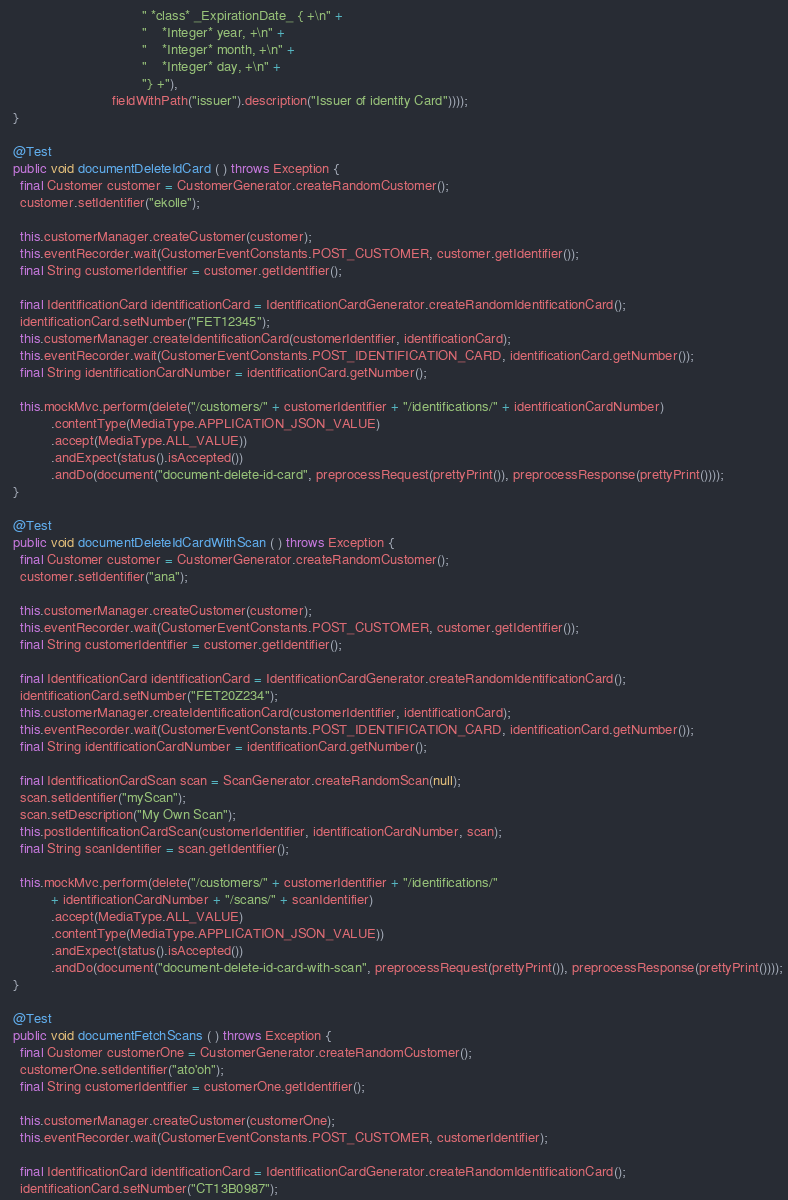Convert code to text. <code><loc_0><loc_0><loc_500><loc_500><_Java_>                                    " *class* _ExpirationDate_ { +\n" +
                                    "    *Integer* year, +\n" +
                                    "    *Integer* month, +\n" +
                                    "    *Integer* day, +\n" +
                                    "} +"),
                            fieldWithPath("issuer").description("Issuer of identity Card"))));
  }

  @Test
  public void documentDeleteIdCard ( ) throws Exception {
    final Customer customer = CustomerGenerator.createRandomCustomer();
    customer.setIdentifier("ekolle");

    this.customerManager.createCustomer(customer);
    this.eventRecorder.wait(CustomerEventConstants.POST_CUSTOMER, customer.getIdentifier());
    final String customerIdentifier = customer.getIdentifier();

    final IdentificationCard identificationCard = IdentificationCardGenerator.createRandomIdentificationCard();
    identificationCard.setNumber("FET12345");
    this.customerManager.createIdentificationCard(customerIdentifier, identificationCard);
    this.eventRecorder.wait(CustomerEventConstants.POST_IDENTIFICATION_CARD, identificationCard.getNumber());
    final String identificationCardNumber = identificationCard.getNumber();

    this.mockMvc.perform(delete("/customers/" + customerIdentifier + "/identifications/" + identificationCardNumber)
            .contentType(MediaType.APPLICATION_JSON_VALUE)
            .accept(MediaType.ALL_VALUE))
            .andExpect(status().isAccepted())
            .andDo(document("document-delete-id-card", preprocessRequest(prettyPrint()), preprocessResponse(prettyPrint())));
  }

  @Test
  public void documentDeleteIdCardWithScan ( ) throws Exception {
    final Customer customer = CustomerGenerator.createRandomCustomer();
    customer.setIdentifier("ana");

    this.customerManager.createCustomer(customer);
    this.eventRecorder.wait(CustomerEventConstants.POST_CUSTOMER, customer.getIdentifier());
    final String customerIdentifier = customer.getIdentifier();

    final IdentificationCard identificationCard = IdentificationCardGenerator.createRandomIdentificationCard();
    identificationCard.setNumber("FET20Z234");
    this.customerManager.createIdentificationCard(customerIdentifier, identificationCard);
    this.eventRecorder.wait(CustomerEventConstants.POST_IDENTIFICATION_CARD, identificationCard.getNumber());
    final String identificationCardNumber = identificationCard.getNumber();

    final IdentificationCardScan scan = ScanGenerator.createRandomScan(null);
    scan.setIdentifier("myScan");
    scan.setDescription("My Own Scan");
    this.postIdentificationCardScan(customerIdentifier, identificationCardNumber, scan);
    final String scanIdentifier = scan.getIdentifier();

    this.mockMvc.perform(delete("/customers/" + customerIdentifier + "/identifications/"
            + identificationCardNumber + "/scans/" + scanIdentifier)
            .accept(MediaType.ALL_VALUE)
            .contentType(MediaType.APPLICATION_JSON_VALUE))
            .andExpect(status().isAccepted())
            .andDo(document("document-delete-id-card-with-scan", preprocessRequest(prettyPrint()), preprocessResponse(prettyPrint())));
  }

  @Test
  public void documentFetchScans ( ) throws Exception {
    final Customer customerOne = CustomerGenerator.createRandomCustomer();
    customerOne.setIdentifier("ato'oh");
    final String customerIdentifier = customerOne.getIdentifier();

    this.customerManager.createCustomer(customerOne);
    this.eventRecorder.wait(CustomerEventConstants.POST_CUSTOMER, customerIdentifier);

    final IdentificationCard identificationCard = IdentificationCardGenerator.createRandomIdentificationCard();
    identificationCard.setNumber("CT13B0987");</code> 